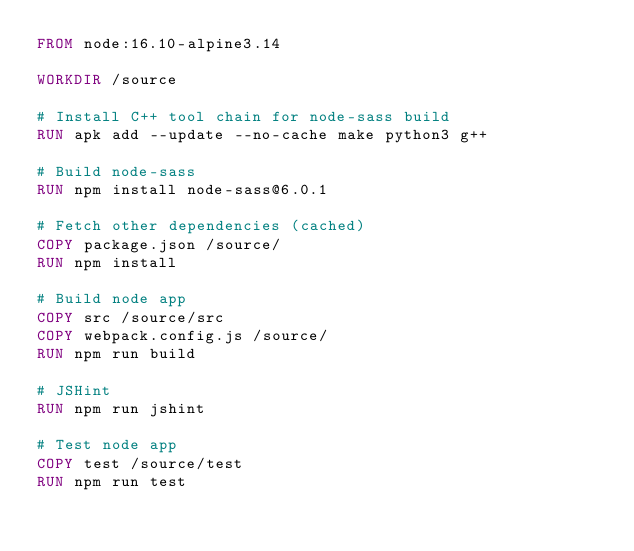<code> <loc_0><loc_0><loc_500><loc_500><_Dockerfile_>FROM node:16.10-alpine3.14

WORKDIR /source

# Install C++ tool chain for node-sass build
RUN apk add --update --no-cache make python3 g++

# Build node-sass
RUN npm install node-sass@6.0.1

# Fetch other dependencies (cached)
COPY package.json /source/
RUN npm install

# Build node app
COPY src /source/src
COPY webpack.config.js /source/
RUN npm run build

# JSHint
RUN npm run jshint

# Test node app
COPY test /source/test
RUN npm run test
</code> 